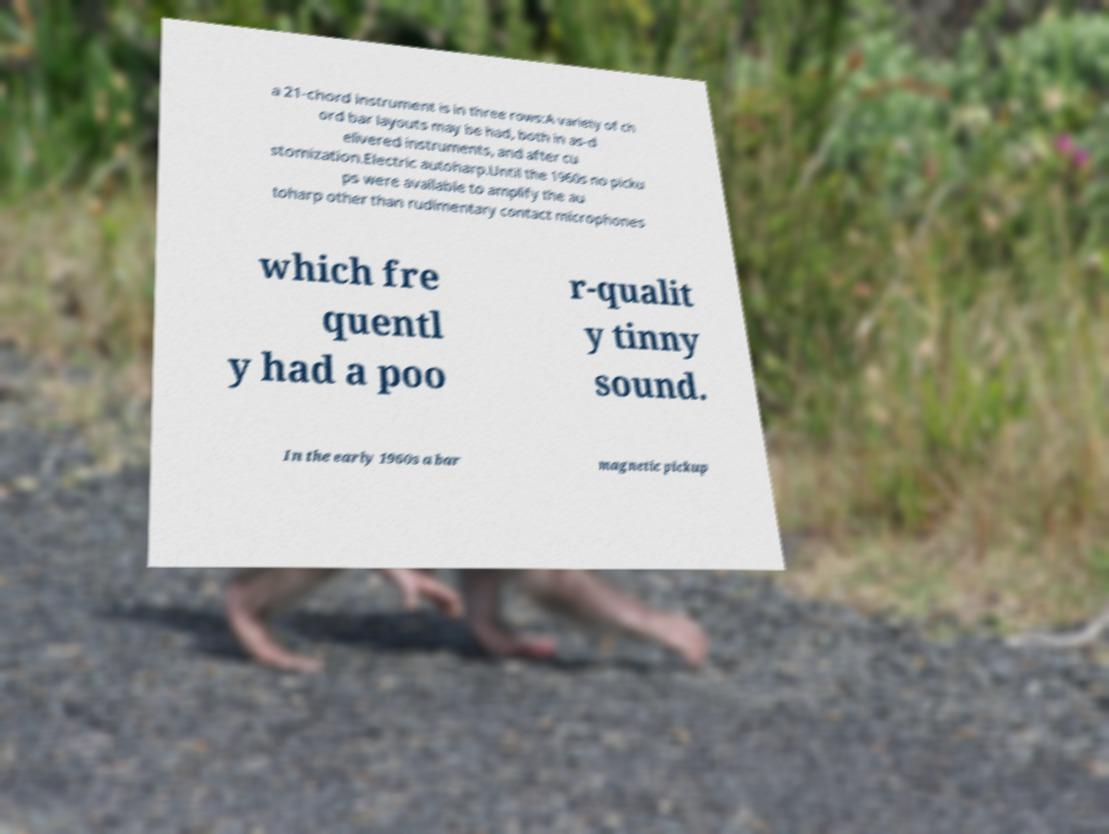For documentation purposes, I need the text within this image transcribed. Could you provide that? a 21-chord instrument is in three rows:A variety of ch ord bar layouts may be had, both in as-d elivered instruments, and after cu stomization.Electric autoharp.Until the 1960s no picku ps were available to amplify the au toharp other than rudimentary contact microphones which fre quentl y had a poo r-qualit y tinny sound. In the early 1960s a bar magnetic pickup 